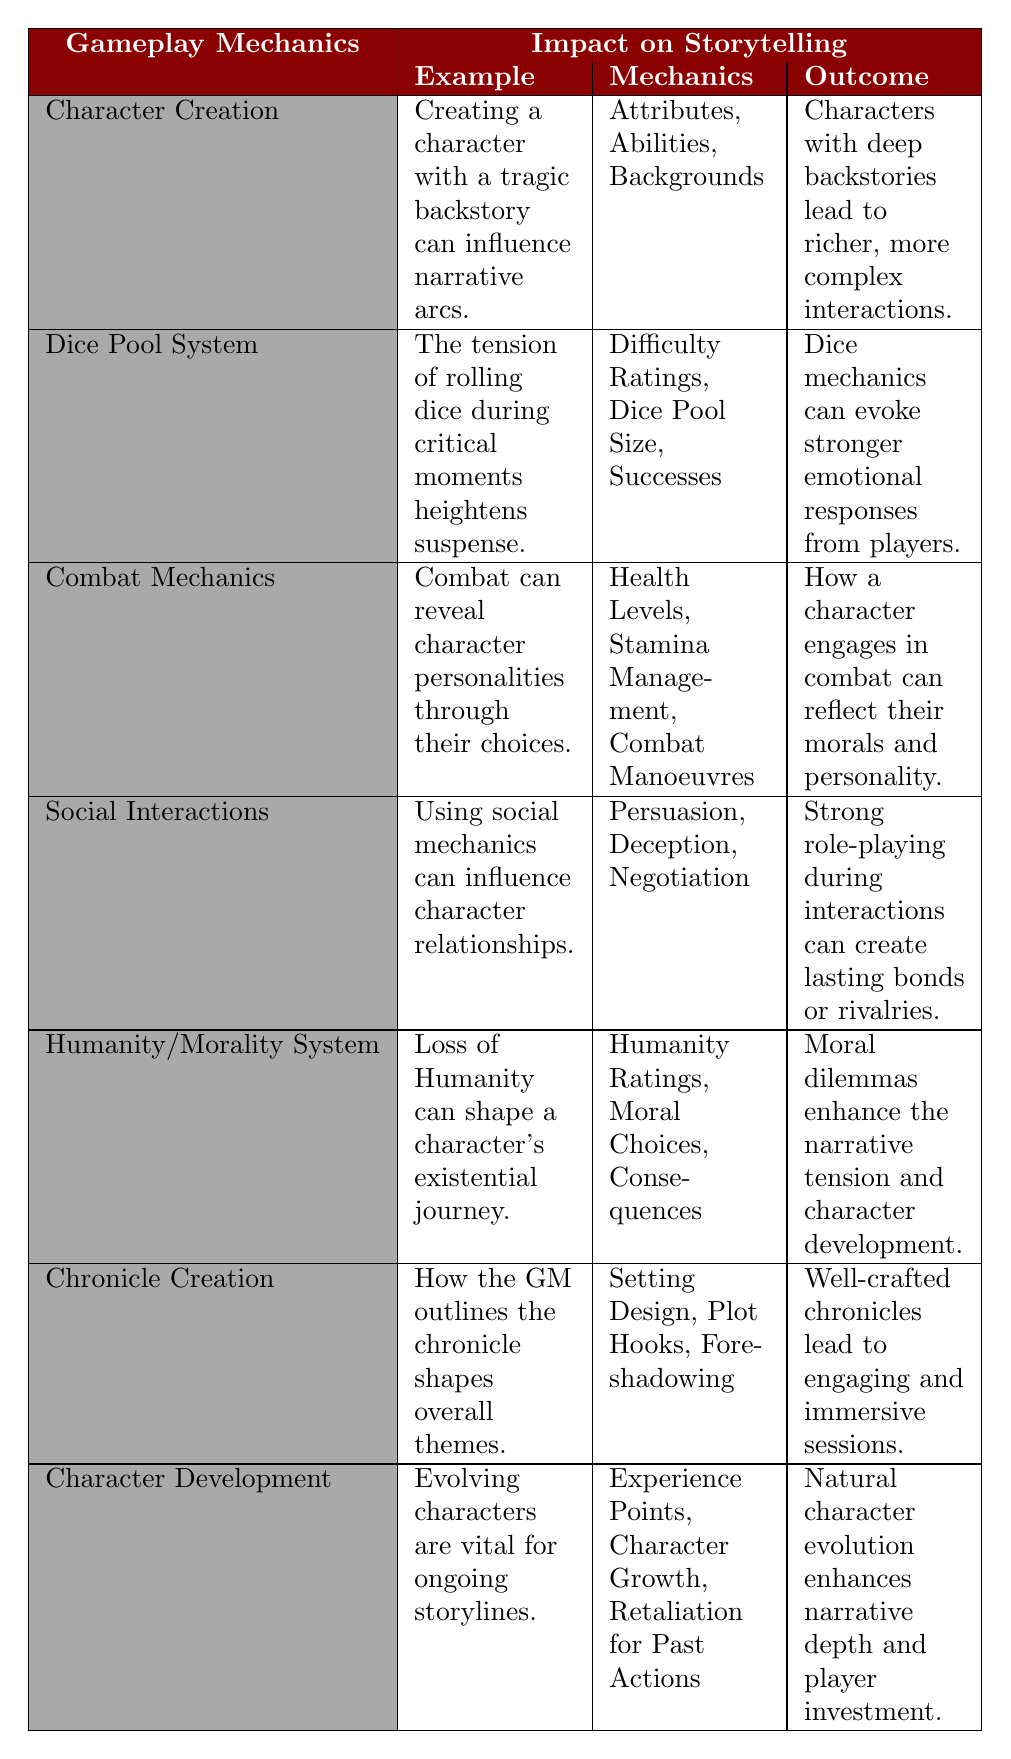What is the example given for the Dice Pool System? The table states that the example for the Dice Pool System is "The tension of rolling dice during critical moments heightens suspense." This is a direct reference found in the corresponding row.
Answer: The tension of rolling dice during critical moments heightens suspense Which mechanics are listed under Character Creation? According to the table, the mechanics listed under Character Creation include "Attributes, Abilities, Backgrounds." This information can be directly retrieved from the corresponding row.
Answer: Attributes, Abilities, Backgrounds Does the Combat Mechanics section state that combat can reveal character personalities? The table contains a true statement in the Combat Mechanics section, which reads "Combat can reveal character personalities through their choices." Thus, the answer to this factual question is reliable.
Answer: Yes How many distinct gameplay mechanics are mentioned in the table? The table lists seven gameplay mechanics: Character Creation, Dice Pool System, Combat Mechanics, Social Interactions, Humanity/Morality System, Chronicle Creation, and Character Development. Counting these mechanics yields a total of seven.
Answer: Seven Based on the table, which gameplay mechanic discusses the evolution of characters and what is its example? From the table, the gameplay mechanic that refers to character evolution is "Character Development," and its example is "Evolving characters are vital for ongoing storylines." Identifying both pieces of information from the relevant section confirms this.
Answer: Character Development, Evolving characters are vital for ongoing storylines What is the outcome mentioned for Social Interactions, and how does it relate to character relationships? The outcome listed for Social Interactions is "Strong role-playing during interactions can create lasting bonds or rivalries." This suggests that how characters engage socially can significantly impact their interpersonal relationships within the narrative.
Answer: Strong role-playing creates lasting bonds or rivalries Analyze the connection between the Humanity/Morality System and narrative tension based on the table. The Humanity/Morality System states that "Loss of Humanity can shape a character’s existential journey," and that the outcome is "Moral dilemmas enhance the narrative tension and character development." By examining these two points, one can see that a character's moral choices directly contribute to increased narrative tension, as they are tied to their development.
Answer: Loss of Humanity enhances narrative tension through moral dilemmas What is the relationship between Chronicle Creation and session engagement found in the table? The table notes that Chronicle Creation involves "How the GM outlines the chronicle shapes overall themes," with the outcome being "Well-crafted chronicles lead to engaging and immersive sessions." This indicates that effective GM planning directly influences player engagement in sessions.
Answer: Proper GM planning leads to engaging sessions 